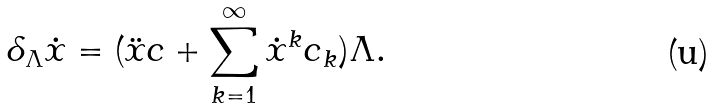Convert formula to latex. <formula><loc_0><loc_0><loc_500><loc_500>\delta _ { \Lambda } \dot { x } = ( \ddot { x } c + \sum _ { k = 1 } ^ { \infty } \dot { x } ^ { k } c _ { k } ) \Lambda .</formula> 